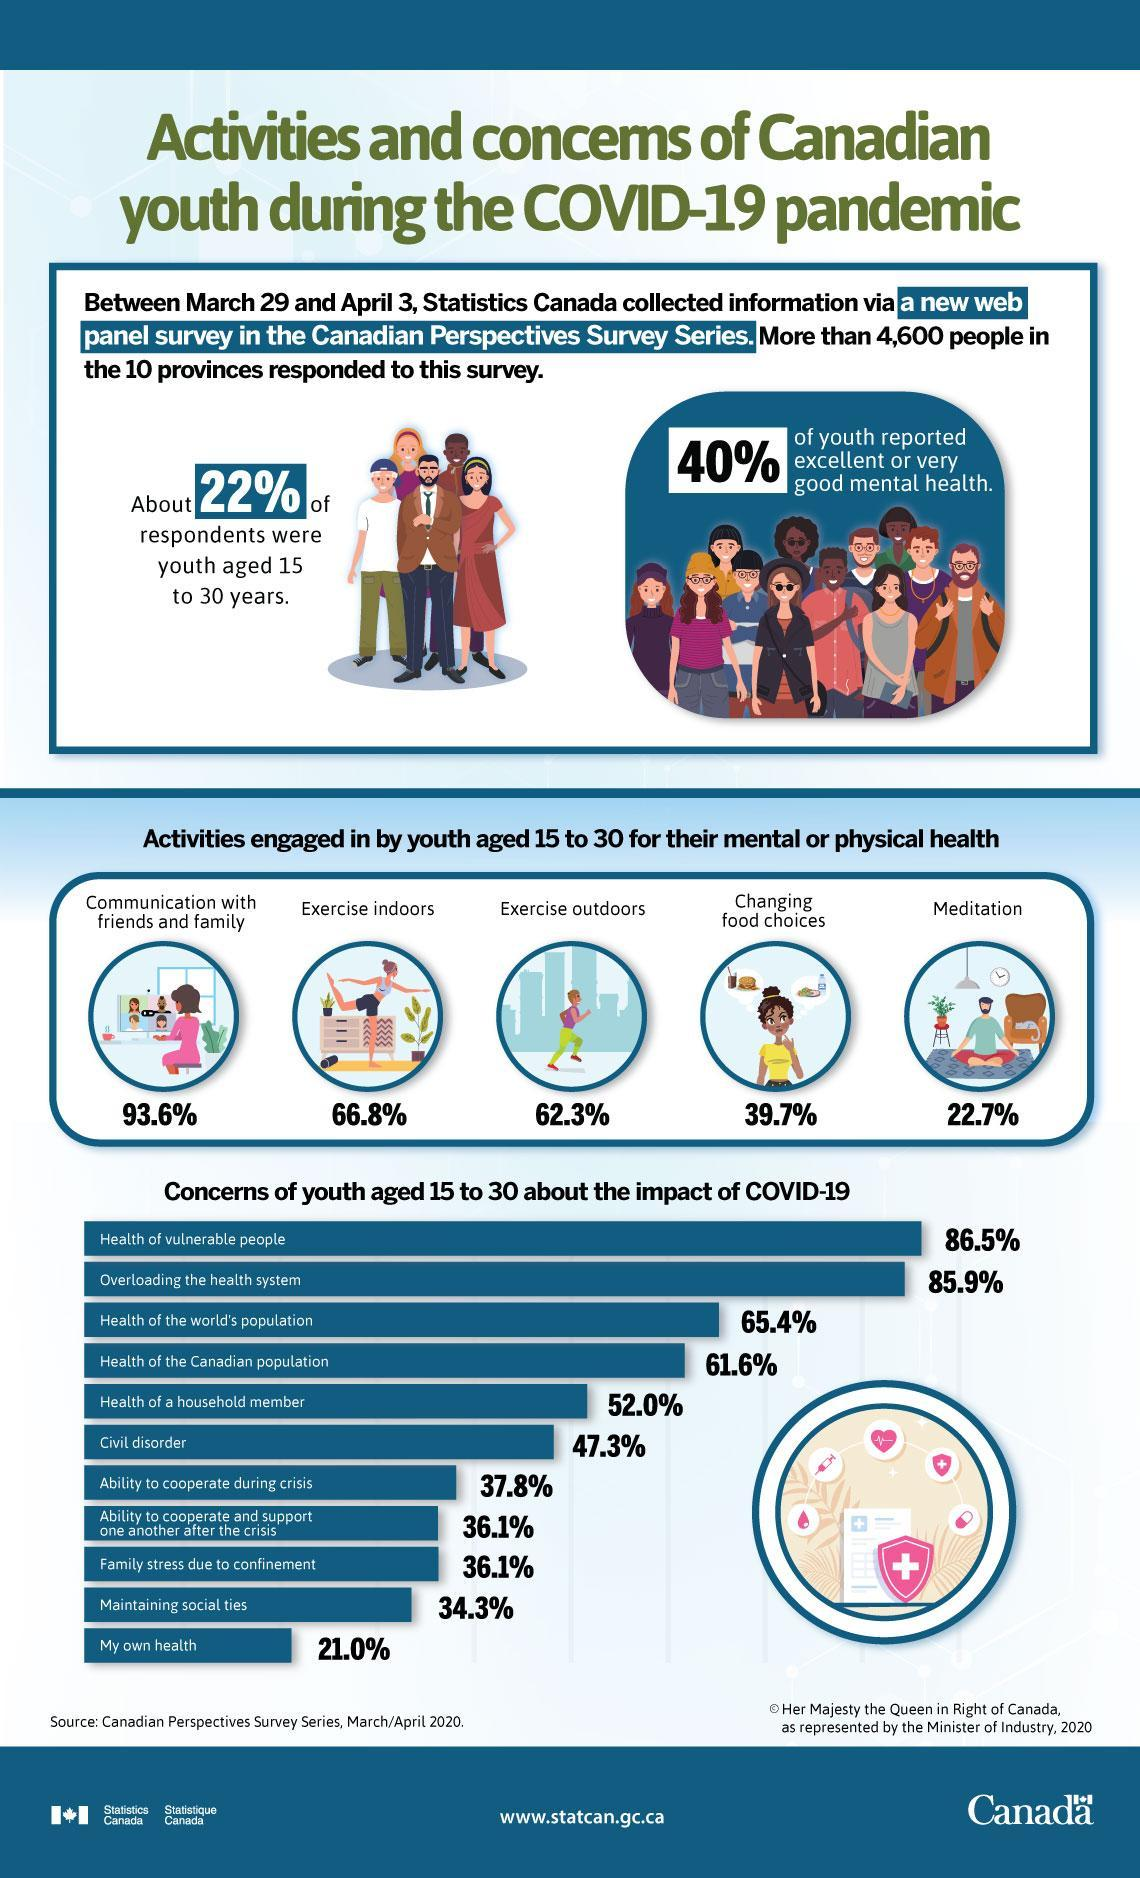What percent of Canadian youth aged 15 to 30 years were not concerned about the health of Canadian population during the COVID-19 as per the survey?
Answer the question with a short phrase. 38.4% What percent of Canadian youth aged 15 to 30 years were not concerned about maintaining social ties during the COVID-19 as per the survey? 65.7% What percent of Canadian youth aged 15 to 30 years were not concerned about their health during the COVID-19 as per the survey? 79.0% What percent of Canadian youth aged 15 to 30 years were engaged in outdoor exercises for maintaining their physical health according to the survey? 62.3% What percent of Canadian youth aged 15 to 30 years were engaged in indoor exercises for maintaining their physical health according to the survey? 66.8% What percent of Canadian youth aged 15 to 30 years were engaged in meditation for their mental health according to the survey? 22.7% 